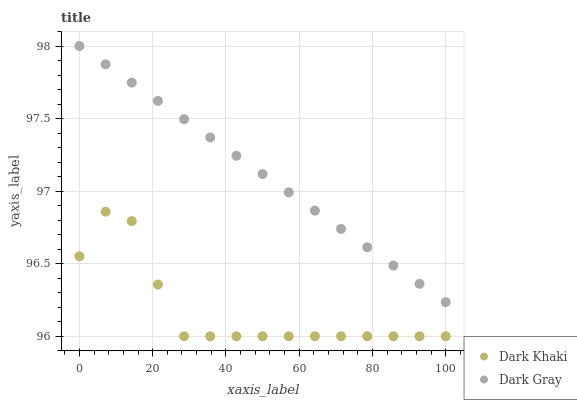Does Dark Khaki have the minimum area under the curve?
Answer yes or no. Yes. Does Dark Gray have the maximum area under the curve?
Answer yes or no. Yes. Does Dark Gray have the minimum area under the curve?
Answer yes or no. No. Is Dark Gray the smoothest?
Answer yes or no. Yes. Is Dark Khaki the roughest?
Answer yes or no. Yes. Is Dark Gray the roughest?
Answer yes or no. No. Does Dark Khaki have the lowest value?
Answer yes or no. Yes. Does Dark Gray have the lowest value?
Answer yes or no. No. Does Dark Gray have the highest value?
Answer yes or no. Yes. Is Dark Khaki less than Dark Gray?
Answer yes or no. Yes. Is Dark Gray greater than Dark Khaki?
Answer yes or no. Yes. Does Dark Khaki intersect Dark Gray?
Answer yes or no. No. 